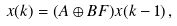<formula> <loc_0><loc_0><loc_500><loc_500>x ( k ) = ( A \oplus B F ) x ( k - 1 ) \, ,</formula> 